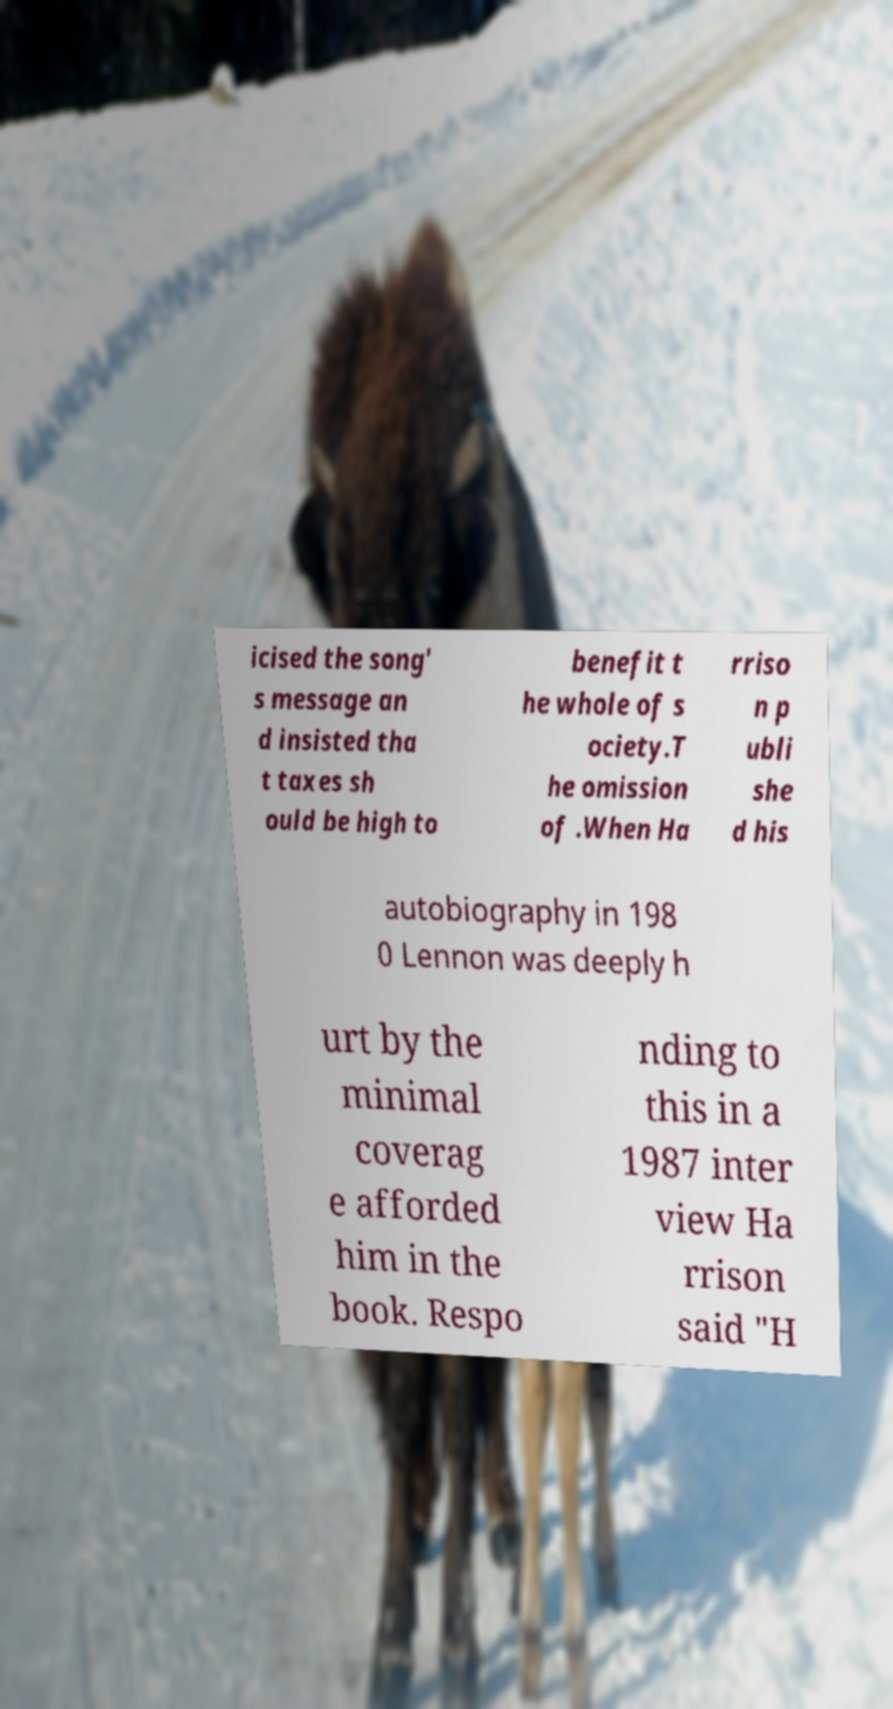For documentation purposes, I need the text within this image transcribed. Could you provide that? icised the song' s message an d insisted tha t taxes sh ould be high to benefit t he whole of s ociety.T he omission of .When Ha rriso n p ubli she d his autobiography in 198 0 Lennon was deeply h urt by the minimal coverag e afforded him in the book. Respo nding to this in a 1987 inter view Ha rrison said "H 